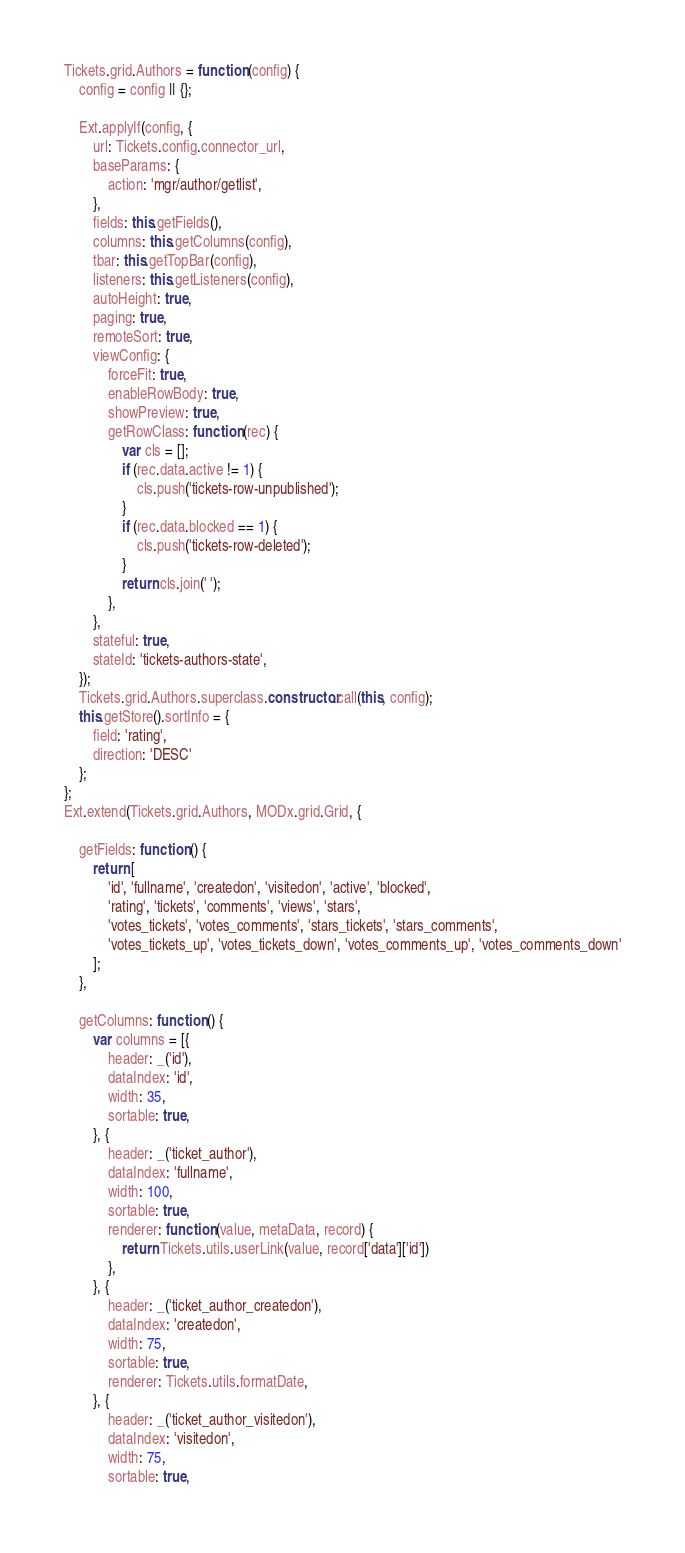<code> <loc_0><loc_0><loc_500><loc_500><_JavaScript_>Tickets.grid.Authors = function (config) {
    config = config || {};

    Ext.applyIf(config, {
        url: Tickets.config.connector_url,
        baseParams: {
            action: 'mgr/author/getlist',
        },
        fields: this.getFields(),
        columns: this.getColumns(config),
        tbar: this.getTopBar(config),
        listeners: this.getListeners(config),
        autoHeight: true,
        paging: true,
        remoteSort: true,
        viewConfig: {
            forceFit: true,
            enableRowBody: true,
            showPreview: true,
            getRowClass: function (rec) {
                var cls = [];
                if (rec.data.active != 1) {
                    cls.push('tickets-row-unpublished');
                }
                if (rec.data.blocked == 1) {
                    cls.push('tickets-row-deleted');
                }
                return cls.join(' ');
            },
        },
        stateful: true,
        stateId: 'tickets-authors-state',
    });
    Tickets.grid.Authors.superclass.constructor.call(this, config);
    this.getStore().sortInfo = {
        field: 'rating',
        direction: 'DESC'
    };
};
Ext.extend(Tickets.grid.Authors, MODx.grid.Grid, {

    getFields: function () {
        return [
            'id', 'fullname', 'createdon', 'visitedon', 'active', 'blocked',
            'rating', 'tickets', 'comments', 'views', 'stars',
            'votes_tickets', 'votes_comments', 'stars_tickets', 'stars_comments',
            'votes_tickets_up', 'votes_tickets_down', 'votes_comments_up', 'votes_comments_down'
        ];
    },

    getColumns: function () {
        var columns = [{
            header: _('id'),
            dataIndex: 'id',
            width: 35,
            sortable: true,
        }, {
            header: _('ticket_author'),
            dataIndex: 'fullname',
            width: 100,
            sortable: true,
            renderer: function (value, metaData, record) {
                return Tickets.utils.userLink(value, record['data']['id'])
            },
        }, {
            header: _('ticket_author_createdon'),
            dataIndex: 'createdon',
            width: 75,
            sortable: true,
            renderer: Tickets.utils.formatDate,
        }, {
            header: _('ticket_author_visitedon'),
            dataIndex: 'visitedon',
            width: 75,
            sortable: true,</code> 